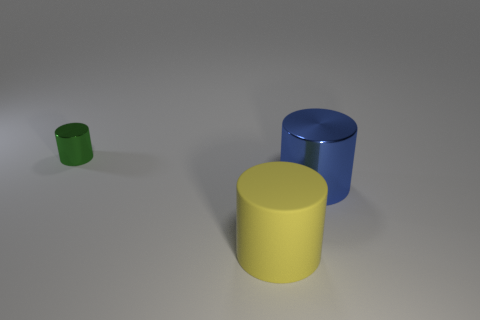What is the material of the thing that is on the right side of the small cylinder and behind the yellow cylinder?
Offer a very short reply. Metal. What is the size of the green metal object?
Give a very brief answer. Small. What number of big yellow matte cylinders are right of the shiny object right of the object that is behind the blue metal object?
Offer a terse response. 0. What shape is the metallic object right of the cylinder left of the big matte object?
Offer a terse response. Cylinder. There is a yellow rubber thing that is the same shape as the green thing; what is its size?
Your answer should be compact. Large. Is there any other thing that is the same size as the yellow rubber cylinder?
Ensure brevity in your answer.  Yes. There is a shiny cylinder that is left of the yellow object; what is its color?
Provide a short and direct response. Green. What is the material of the large thing on the right side of the big cylinder in front of the metallic thing that is in front of the green metal cylinder?
Your answer should be very brief. Metal. There is a cylinder on the left side of the big cylinder in front of the large metallic cylinder; what is its size?
Give a very brief answer. Small. The other large shiny thing that is the same shape as the green metal object is what color?
Your answer should be very brief. Blue. 